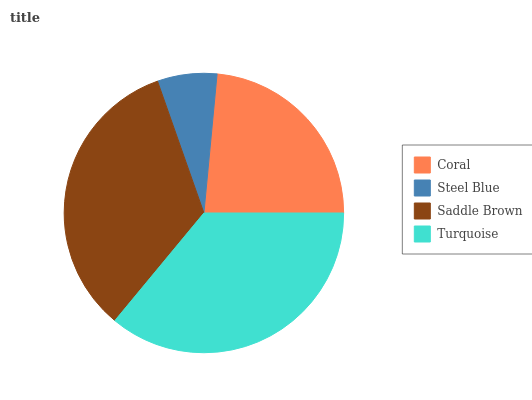Is Steel Blue the minimum?
Answer yes or no. Yes. Is Turquoise the maximum?
Answer yes or no. Yes. Is Saddle Brown the minimum?
Answer yes or no. No. Is Saddle Brown the maximum?
Answer yes or no. No. Is Saddle Brown greater than Steel Blue?
Answer yes or no. Yes. Is Steel Blue less than Saddle Brown?
Answer yes or no. Yes. Is Steel Blue greater than Saddle Brown?
Answer yes or no. No. Is Saddle Brown less than Steel Blue?
Answer yes or no. No. Is Saddle Brown the high median?
Answer yes or no. Yes. Is Coral the low median?
Answer yes or no. Yes. Is Coral the high median?
Answer yes or no. No. Is Steel Blue the low median?
Answer yes or no. No. 